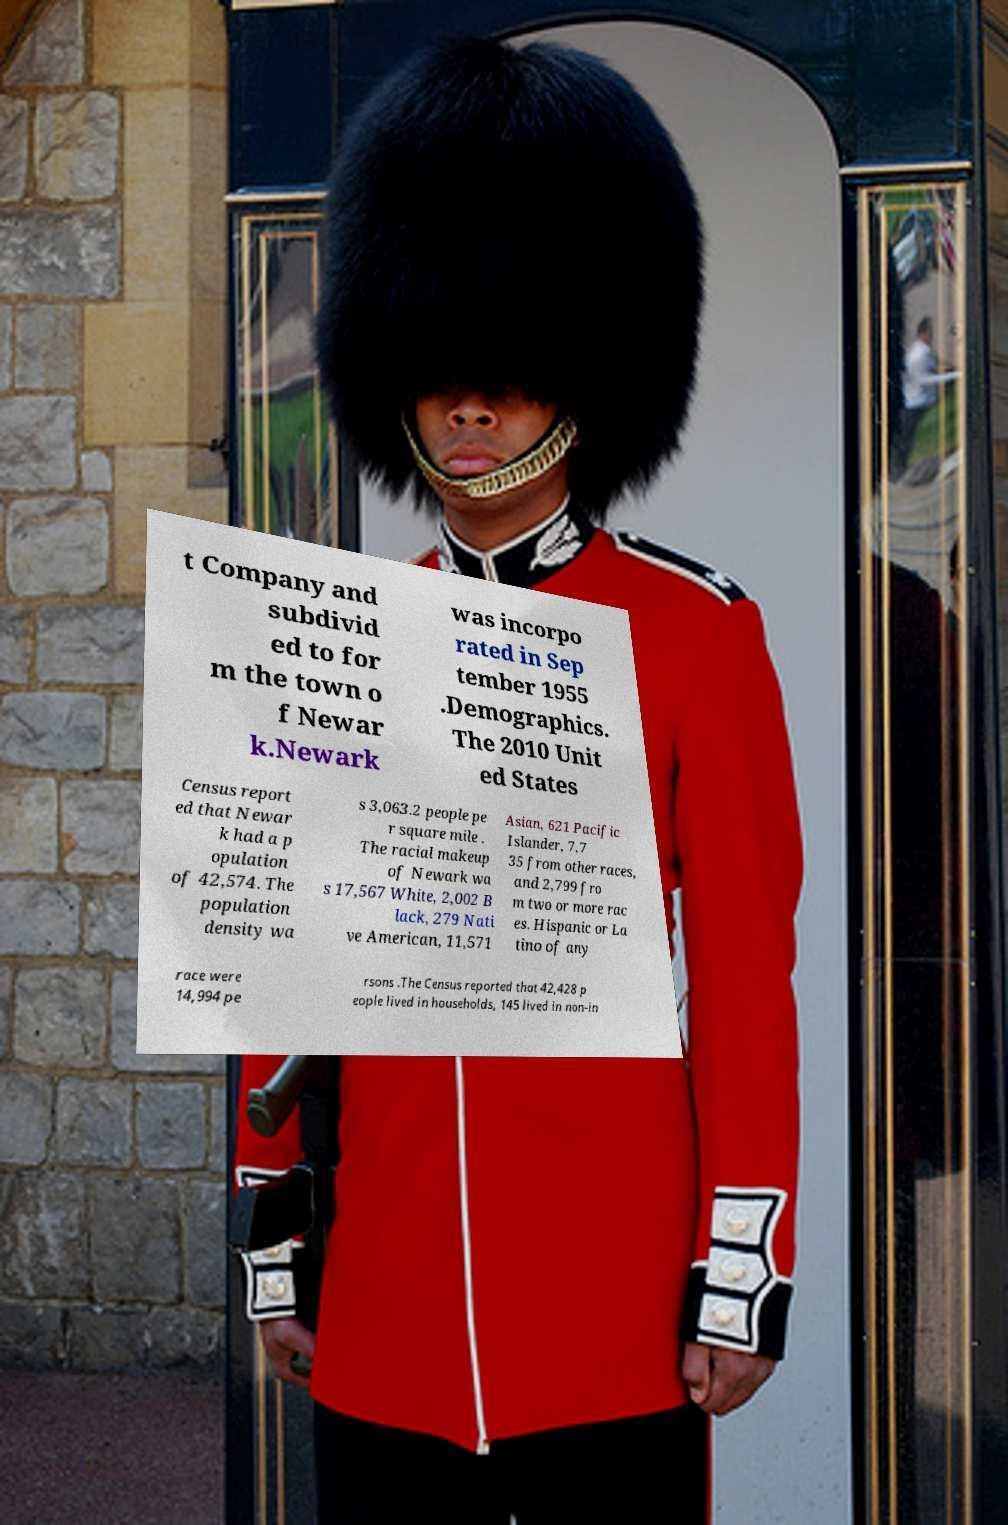What messages or text are displayed in this image? I need them in a readable, typed format. t Company and subdivid ed to for m the town o f Newar k.Newark was incorpo rated in Sep tember 1955 .Demographics. The 2010 Unit ed States Census report ed that Newar k had a p opulation of 42,574. The population density wa s 3,063.2 people pe r square mile . The racial makeup of Newark wa s 17,567 White, 2,002 B lack, 279 Nati ve American, 11,571 Asian, 621 Pacific Islander, 7,7 35 from other races, and 2,799 fro m two or more rac es. Hispanic or La tino of any race were 14,994 pe rsons .The Census reported that 42,428 p eople lived in households, 145 lived in non-in 